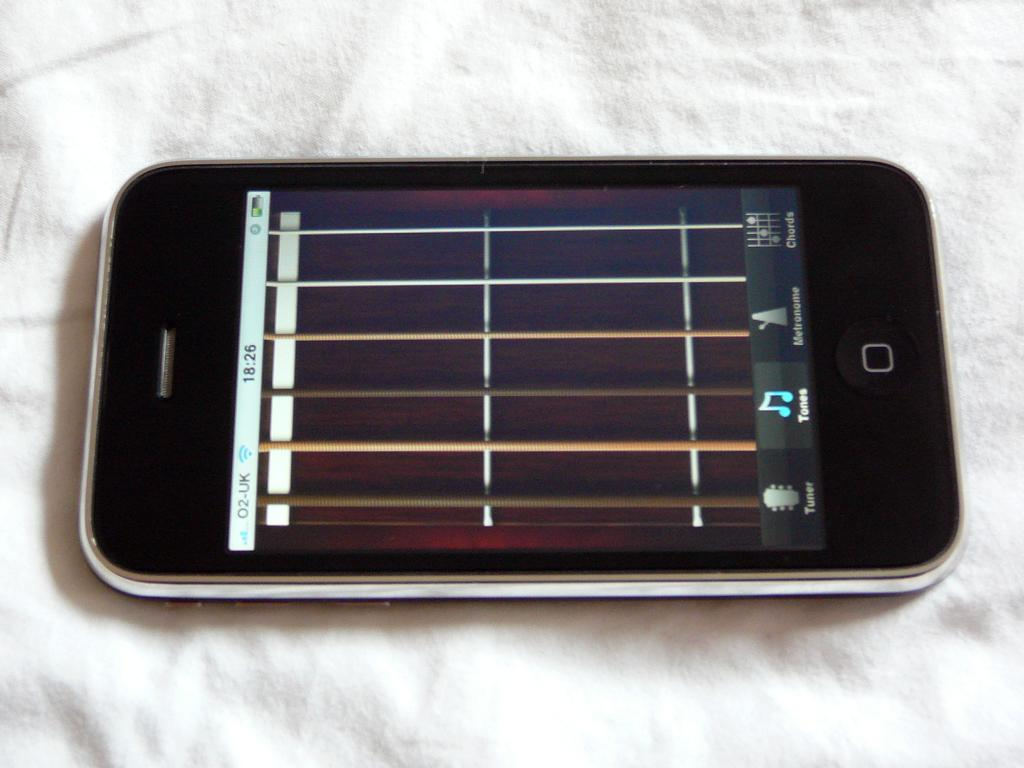<image>
Provide a brief description of the given image. A black smartphone with the display screen showing 18:26 